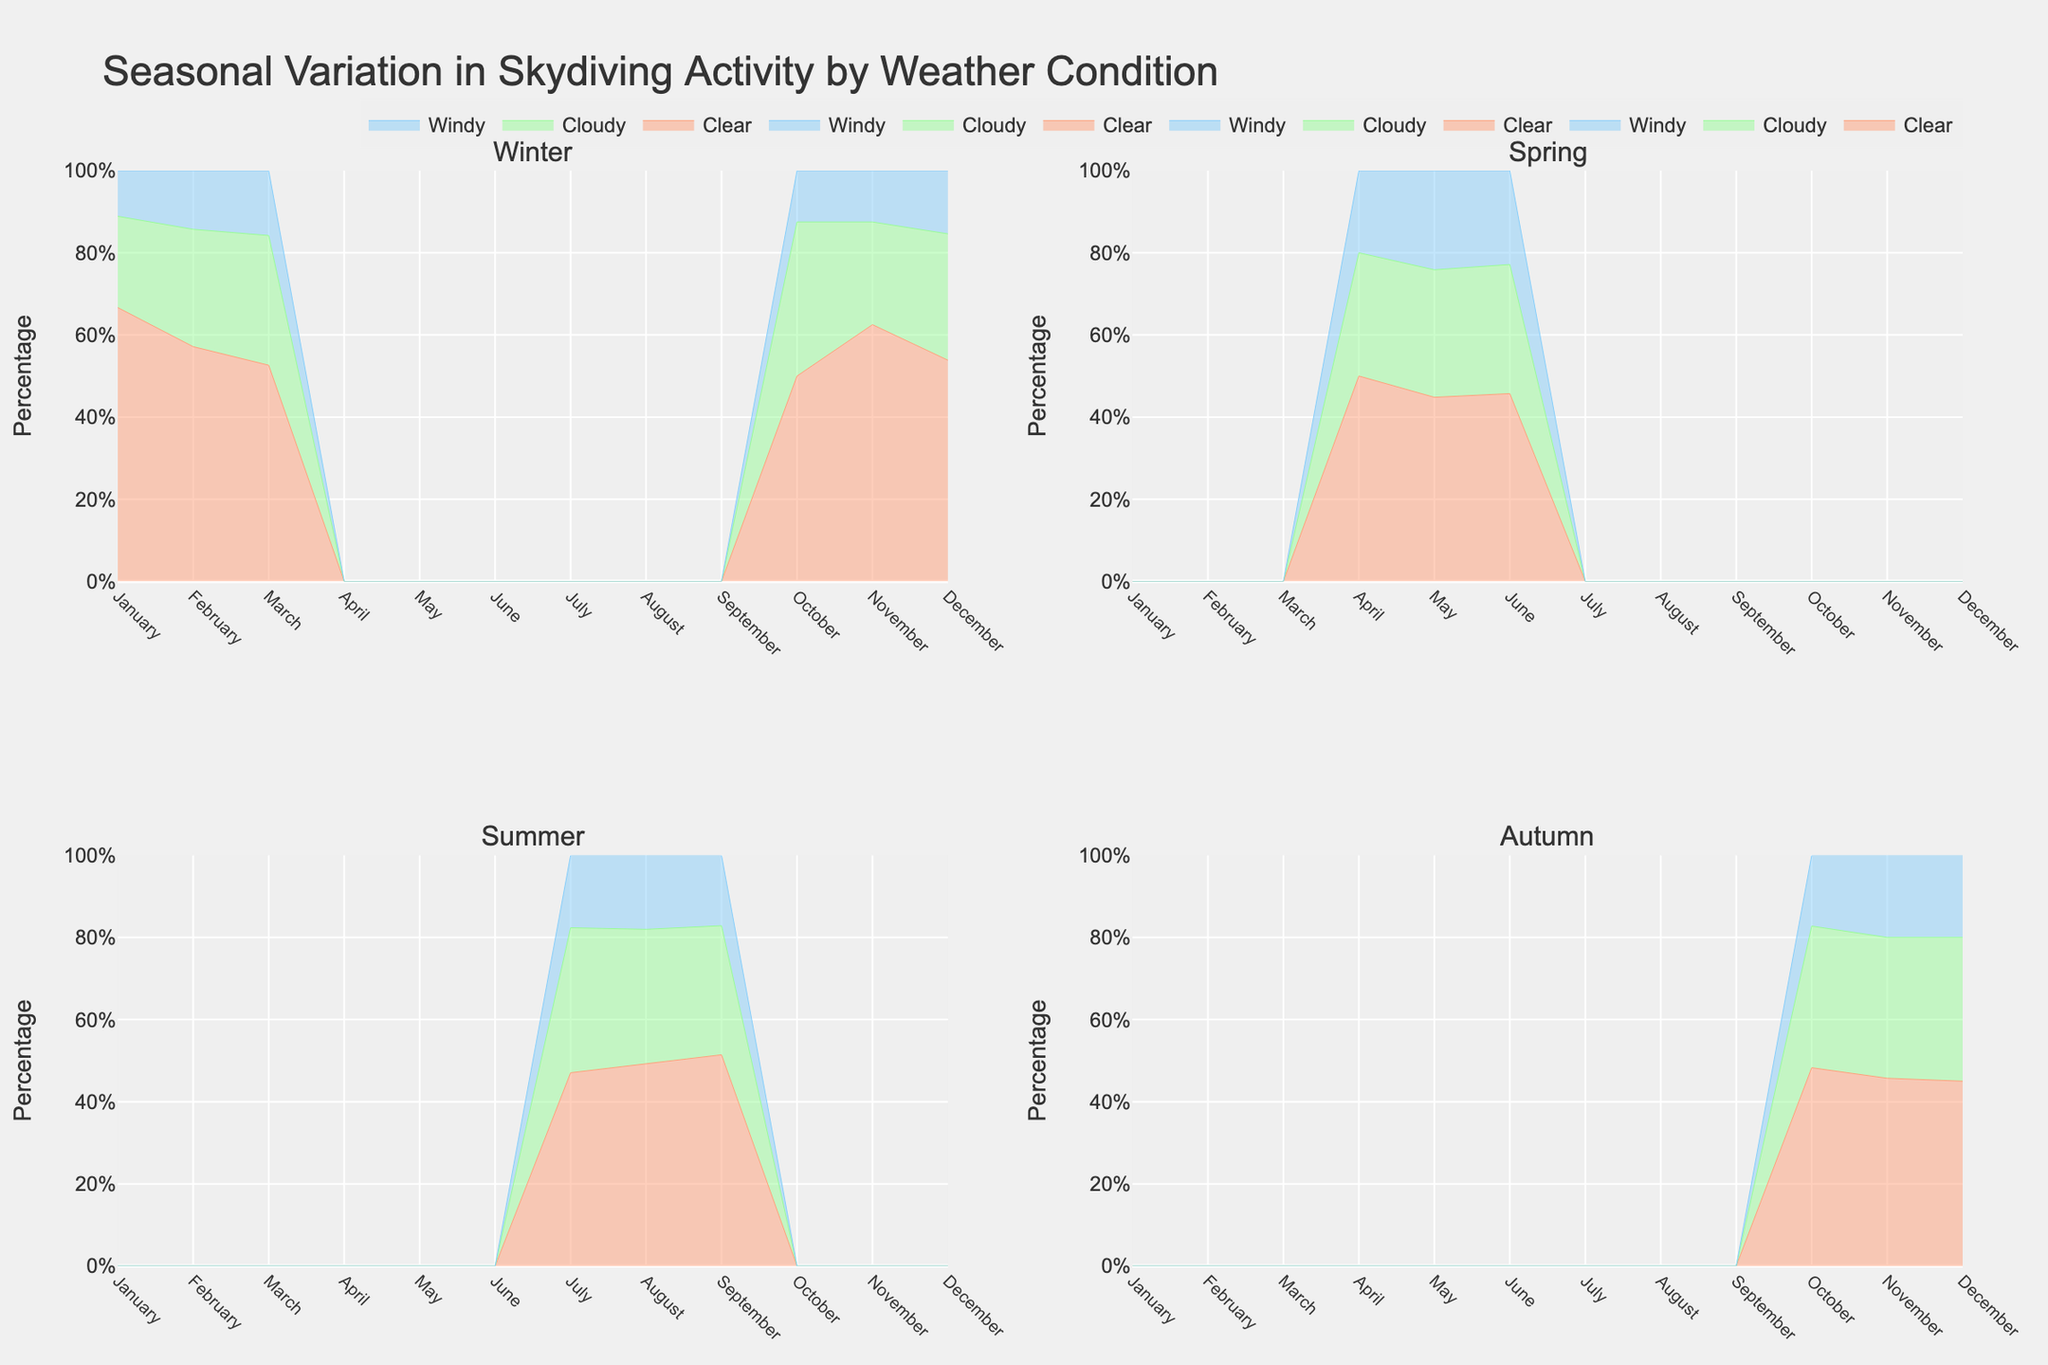How many weather conditions are shown in each subplot? Each subplot has three weather conditions represented by different line colors. These are Clear, Cloudy, and Windy.
Answer: 3 Which season shows the highest percentage of clear skydiving activity? By looking at the four subplots, Summer has the highest spikes for Clear weather conditions, reaching up to 60% in August.
Answer: Summer What is the trend of skydiving activity under clear weather during autumn? The percentage increases gradually, starting at around 40% in October, then 50% in November, and finally reaching 60% in December. This can be observed from the rising lines in Autumn's subplot.
Answer: Increasing Compare the skydiving activity on cloudy days in Spring and Summer. In Spring, the Cloudy condition is present in April, May, and June, peaking around 45%. In Summer, it picks up in July, August, and September with the peak around 50-55%.
Answer: Higher in Summer How does skydiving activity change under windy conditions from January to March in Winter? The Windy condition in Winter shows an increasing trend from 5% in January, peaking at around 15% in March. This is evident from the gradually rising line in Winter's subplot.
Answer: Increasing During which months is there no skydiving activity in Winter? By observing the Winter subplot, there are no skydiving activities from April to September as the area under all weather conditions is zero.
Answer: April to September What percentage does skydiving activity under clear conditions reach in Spring? Skydiving activity under Clear weather in Spring reaches its highest peak in June at 80%.
Answer: 80% Compare skydiving activity under windy conditions in Summer and Autumn. In Summer, Windy conditions show peak activity reaching around 25% in August, while in Autumn it peaks at around 20% in October but decreases afterwards. This suggests higher Windy activity in Summer.
Answer: Higher in Summer Describe the variation in skydiving activities under cloudy conditions throughout the year. Cloudy weather conditions have varying percentages, starting low in Winter, increasing to around 45% in Spring, peaking at around 55% in Summer, and dropping to 50% in Autumn, showing a general pattern of increase from Winter to Summer and a slight decrease in Autumn.
Answer: Variable Which month has the lowest skydiving activity across any weather condition in the Summer season? Observing the Summer subplot, the activity is lowest in July where the percentage under Clear, Cloudy, and Windy conditions all start to rise but are not yet high, suggesting the lowest total activity.
Answer: July 